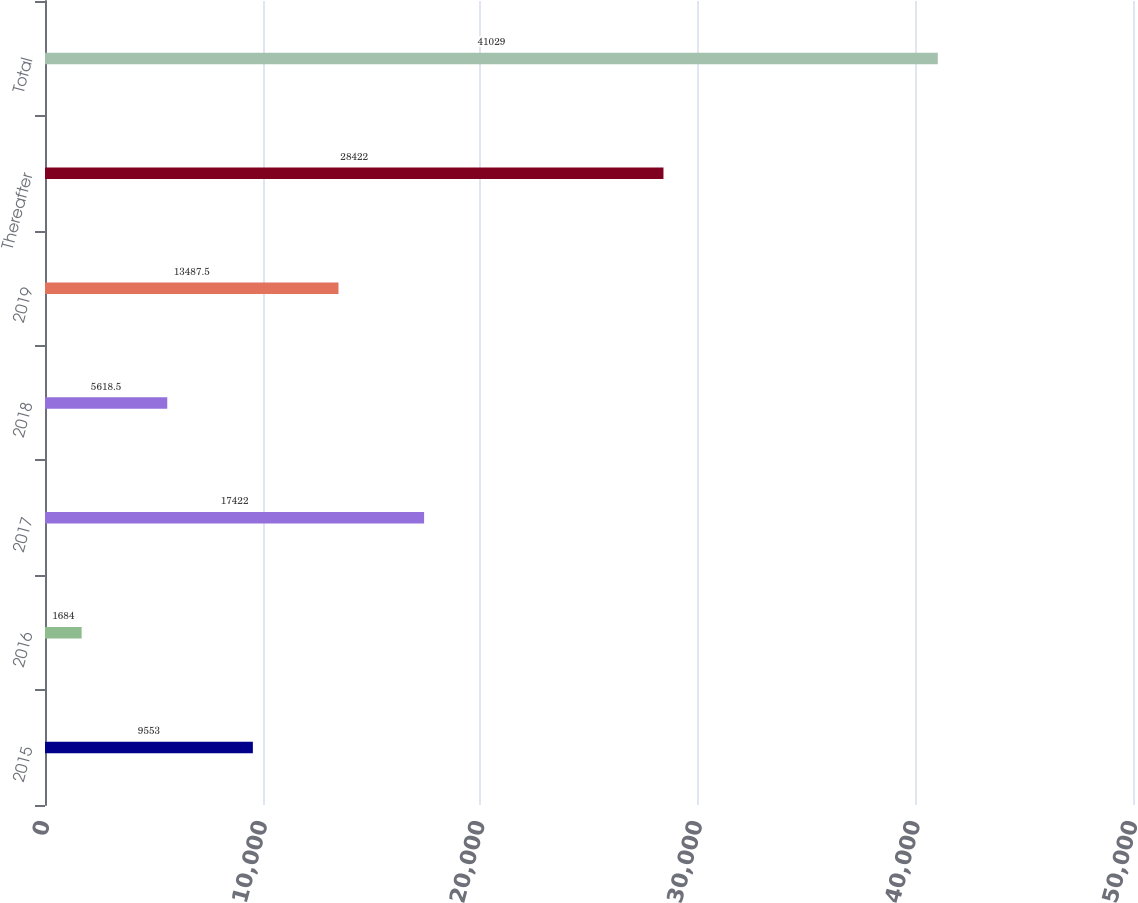Convert chart to OTSL. <chart><loc_0><loc_0><loc_500><loc_500><bar_chart><fcel>2015<fcel>2016<fcel>2017<fcel>2018<fcel>2019<fcel>Thereafter<fcel>Total<nl><fcel>9553<fcel>1684<fcel>17422<fcel>5618.5<fcel>13487.5<fcel>28422<fcel>41029<nl></chart> 